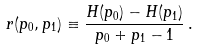<formula> <loc_0><loc_0><loc_500><loc_500>r ( p _ { 0 } , p _ { 1 } ) \equiv \frac { H ( p _ { 0 } ) - H ( p _ { 1 } ) } { p _ { 0 } + p _ { 1 } - 1 } \, .</formula> 